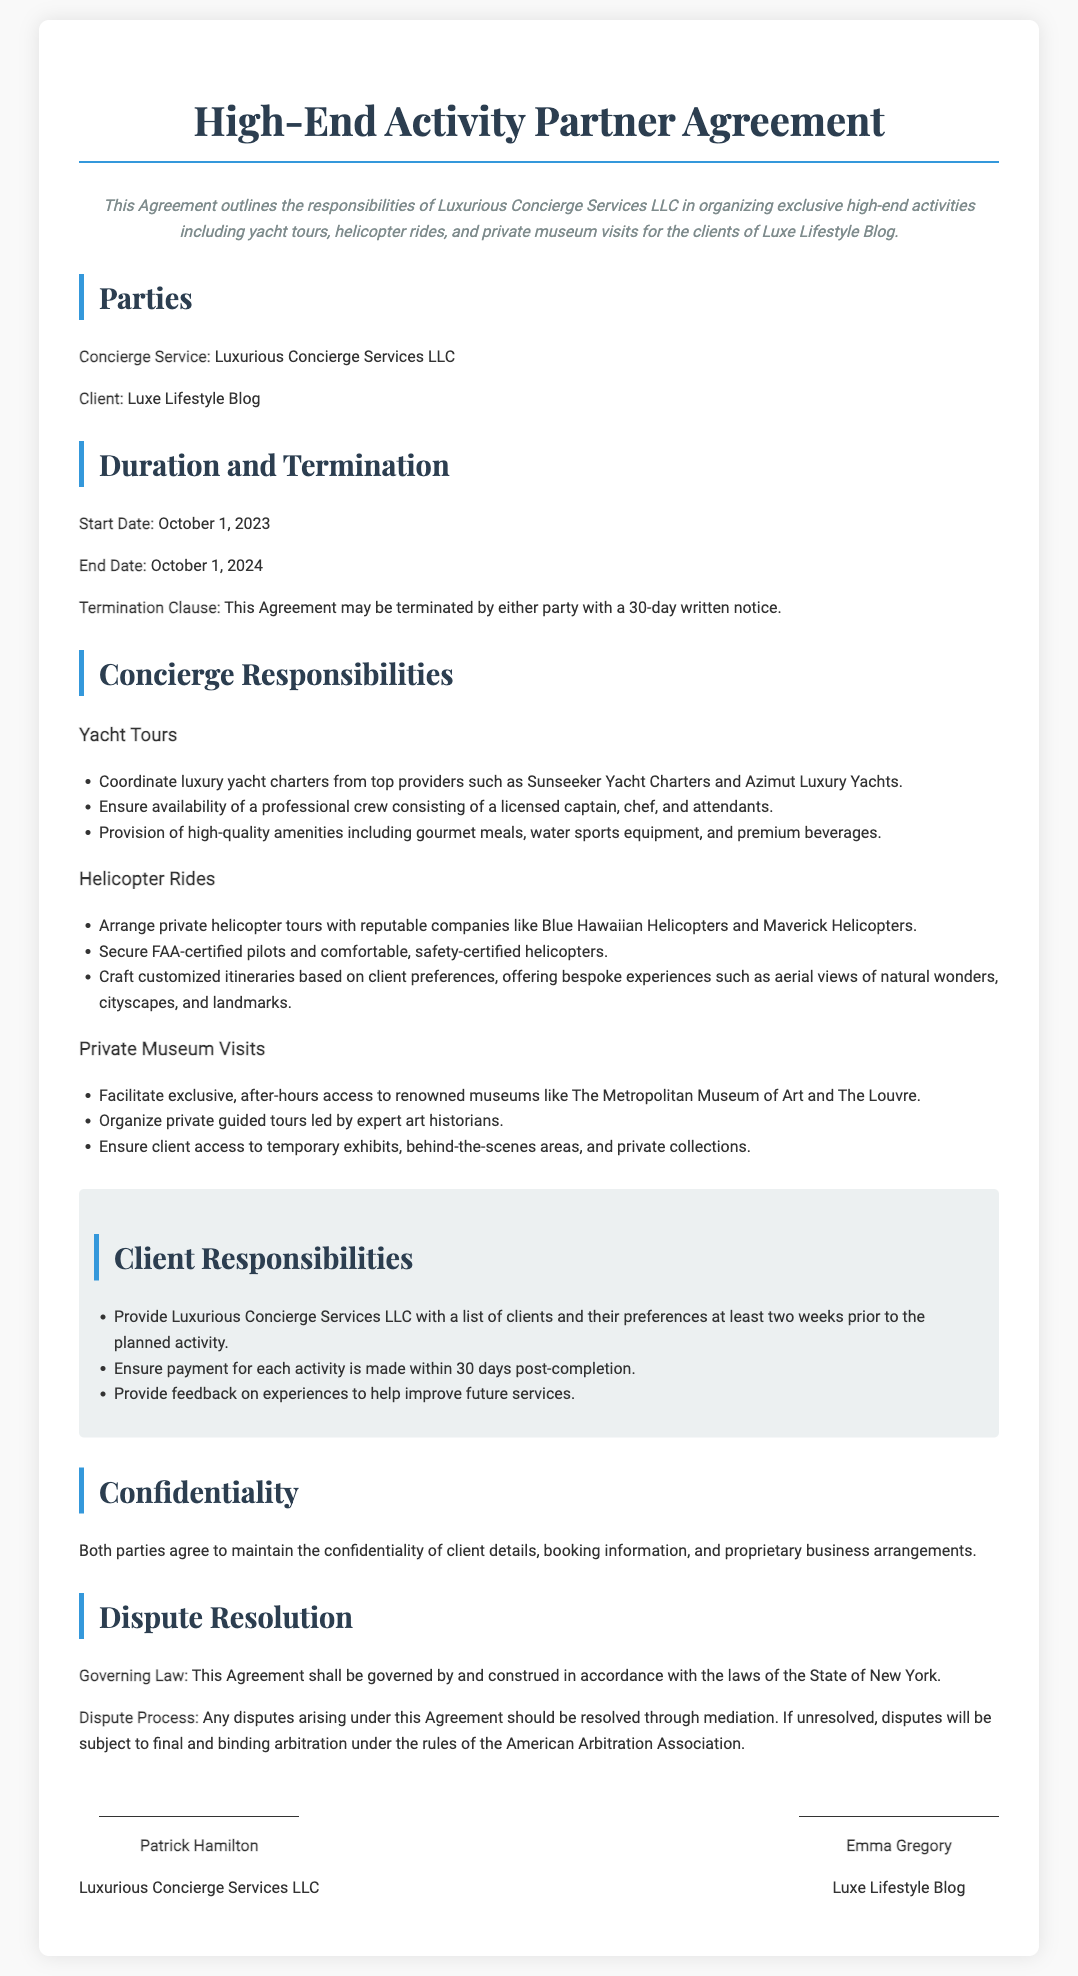What is the name of the concierge service? The document specifies the concierge service as Luxurious Concierge Services LLC.
Answer: Luxurious Concierge Services LLC What is the start date of the agreement? The document mentions the start date as October 1, 2023.
Answer: October 1, 2023 How long is the duration of the agreement? The agreement lasts for one year, from October 1, 2023, to October 1, 2024.
Answer: One year Who is responsible for arranging luxury yacht charters? The responsibilities section states that Luxurious Concierge Services LLC is responsible for coordinating yacht charters.
Answer: Luxurious Concierge Services LLC What type of tours does the concierge organize for helicopter rides? The document states that the concierge arranges private helicopter tours.
Answer: Private helicopter tours What is required for private museum visits according to the responsibilities? The document specifies arranging exclusive, after-hours access to renowned museums.
Answer: Exclusive, after-hours access How much notice is needed for termination of the agreement? The termination clause states that either party can terminate the agreement with a 30-day written notice.
Answer: 30 days Who signed the agreement on behalf of the concierge service? The document lists Patrick Hamilton as the signatory from Luxurious Concierge Services LLC.
Answer: Patrick Hamilton What will disputes be resolved through according to the document? The document outlines that disputes should be resolved through mediation.
Answer: Mediation 